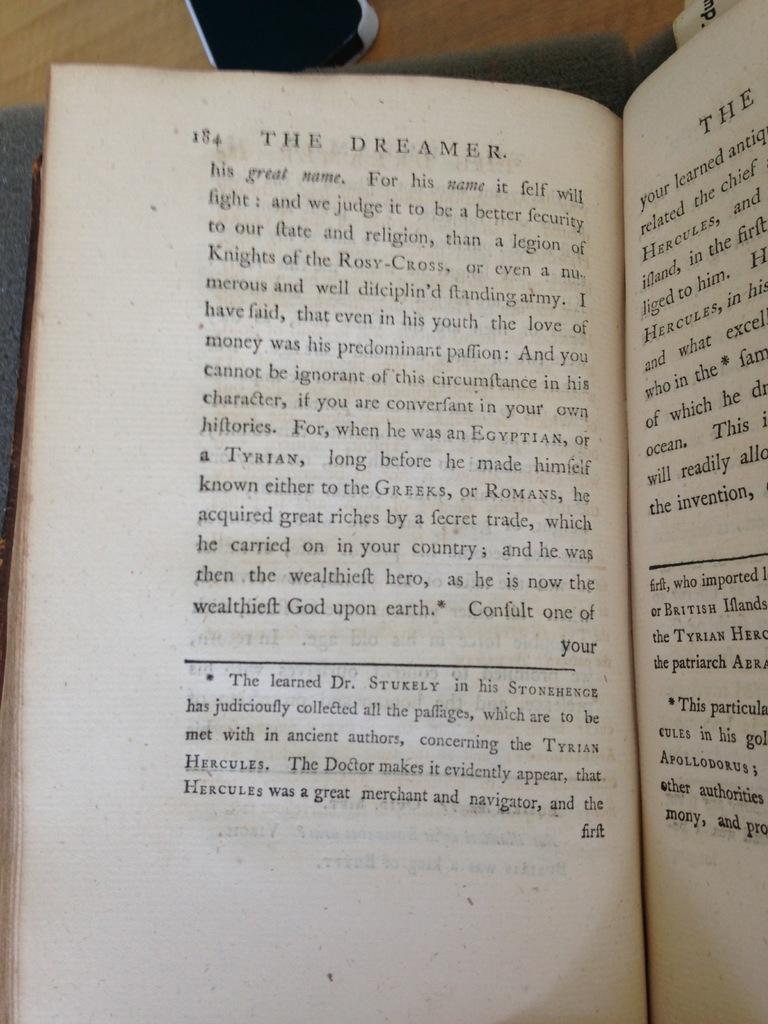What page is this reader currently reading?
Ensure brevity in your answer.  184. What's the title of this book?
Offer a terse response. The dreamer. 